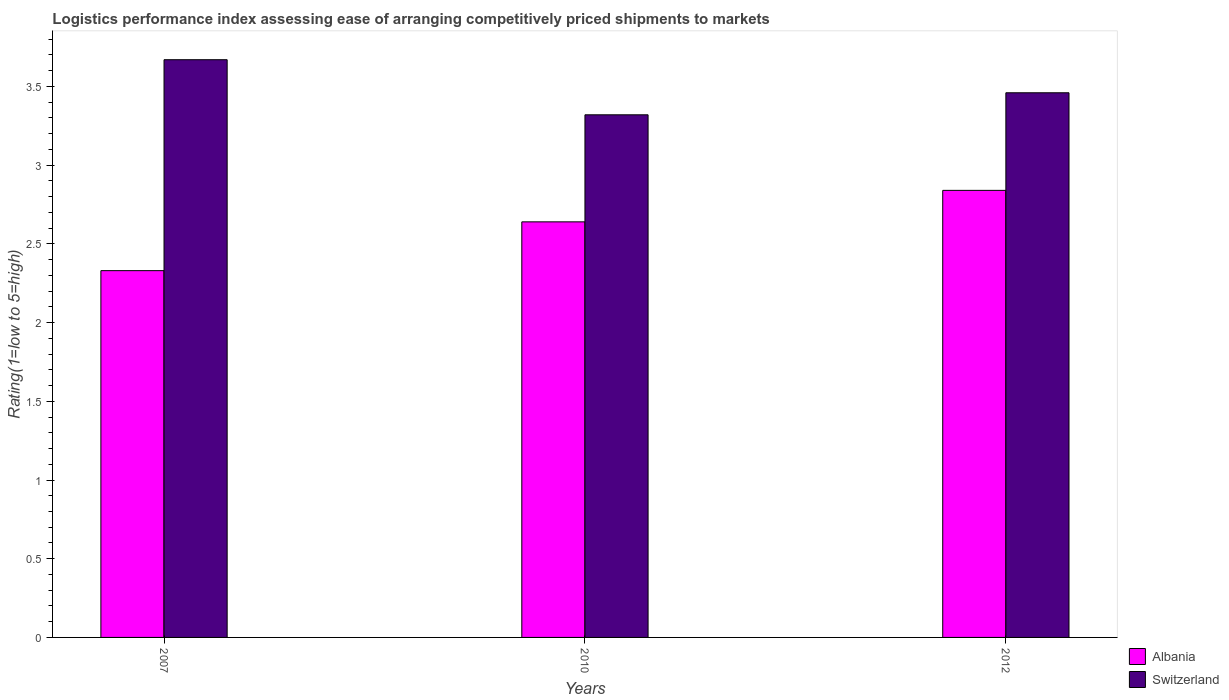How many different coloured bars are there?
Keep it short and to the point. 2. Are the number of bars on each tick of the X-axis equal?
Keep it short and to the point. Yes. How many bars are there on the 3rd tick from the left?
Ensure brevity in your answer.  2. What is the label of the 3rd group of bars from the left?
Ensure brevity in your answer.  2012. What is the Logistic performance index in Switzerland in 2010?
Offer a very short reply. 3.32. Across all years, what is the maximum Logistic performance index in Switzerland?
Your answer should be very brief. 3.67. Across all years, what is the minimum Logistic performance index in Switzerland?
Your answer should be compact. 3.32. In which year was the Logistic performance index in Switzerland minimum?
Provide a succinct answer. 2010. What is the total Logistic performance index in Switzerland in the graph?
Offer a very short reply. 10.45. What is the difference between the Logistic performance index in Switzerland in 2007 and that in 2012?
Your answer should be very brief. 0.21. What is the difference between the Logistic performance index in Albania in 2007 and the Logistic performance index in Switzerland in 2010?
Make the answer very short. -0.99. What is the average Logistic performance index in Albania per year?
Ensure brevity in your answer.  2.6. In the year 2007, what is the difference between the Logistic performance index in Switzerland and Logistic performance index in Albania?
Offer a very short reply. 1.34. What is the ratio of the Logistic performance index in Albania in 2007 to that in 2012?
Provide a short and direct response. 0.82. Is the difference between the Logistic performance index in Switzerland in 2007 and 2012 greater than the difference between the Logistic performance index in Albania in 2007 and 2012?
Provide a succinct answer. Yes. What is the difference between the highest and the second highest Logistic performance index in Albania?
Keep it short and to the point. 0.2. What is the difference between the highest and the lowest Logistic performance index in Albania?
Provide a short and direct response. 0.51. In how many years, is the Logistic performance index in Switzerland greater than the average Logistic performance index in Switzerland taken over all years?
Keep it short and to the point. 1. What does the 1st bar from the left in 2010 represents?
Your answer should be very brief. Albania. What does the 2nd bar from the right in 2012 represents?
Offer a very short reply. Albania. How many years are there in the graph?
Keep it short and to the point. 3. Are the values on the major ticks of Y-axis written in scientific E-notation?
Your response must be concise. No. Where does the legend appear in the graph?
Your answer should be very brief. Bottom right. How are the legend labels stacked?
Your answer should be very brief. Vertical. What is the title of the graph?
Ensure brevity in your answer.  Logistics performance index assessing ease of arranging competitively priced shipments to markets. What is the label or title of the X-axis?
Your answer should be very brief. Years. What is the label or title of the Y-axis?
Make the answer very short. Rating(1=low to 5=high). What is the Rating(1=low to 5=high) of Albania in 2007?
Provide a succinct answer. 2.33. What is the Rating(1=low to 5=high) of Switzerland in 2007?
Offer a terse response. 3.67. What is the Rating(1=low to 5=high) in Albania in 2010?
Make the answer very short. 2.64. What is the Rating(1=low to 5=high) of Switzerland in 2010?
Provide a short and direct response. 3.32. What is the Rating(1=low to 5=high) in Albania in 2012?
Provide a short and direct response. 2.84. What is the Rating(1=low to 5=high) of Switzerland in 2012?
Your answer should be compact. 3.46. Across all years, what is the maximum Rating(1=low to 5=high) in Albania?
Your answer should be compact. 2.84. Across all years, what is the maximum Rating(1=low to 5=high) in Switzerland?
Your answer should be very brief. 3.67. Across all years, what is the minimum Rating(1=low to 5=high) in Albania?
Your response must be concise. 2.33. Across all years, what is the minimum Rating(1=low to 5=high) in Switzerland?
Ensure brevity in your answer.  3.32. What is the total Rating(1=low to 5=high) in Albania in the graph?
Your answer should be very brief. 7.81. What is the total Rating(1=low to 5=high) in Switzerland in the graph?
Offer a terse response. 10.45. What is the difference between the Rating(1=low to 5=high) in Albania in 2007 and that in 2010?
Make the answer very short. -0.31. What is the difference between the Rating(1=low to 5=high) in Switzerland in 2007 and that in 2010?
Keep it short and to the point. 0.35. What is the difference between the Rating(1=low to 5=high) of Albania in 2007 and that in 2012?
Provide a short and direct response. -0.51. What is the difference between the Rating(1=low to 5=high) in Switzerland in 2007 and that in 2012?
Ensure brevity in your answer.  0.21. What is the difference between the Rating(1=low to 5=high) of Switzerland in 2010 and that in 2012?
Ensure brevity in your answer.  -0.14. What is the difference between the Rating(1=low to 5=high) of Albania in 2007 and the Rating(1=low to 5=high) of Switzerland in 2010?
Ensure brevity in your answer.  -0.99. What is the difference between the Rating(1=low to 5=high) in Albania in 2007 and the Rating(1=low to 5=high) in Switzerland in 2012?
Provide a short and direct response. -1.13. What is the difference between the Rating(1=low to 5=high) in Albania in 2010 and the Rating(1=low to 5=high) in Switzerland in 2012?
Give a very brief answer. -0.82. What is the average Rating(1=low to 5=high) in Albania per year?
Make the answer very short. 2.6. What is the average Rating(1=low to 5=high) of Switzerland per year?
Your answer should be compact. 3.48. In the year 2007, what is the difference between the Rating(1=low to 5=high) of Albania and Rating(1=low to 5=high) of Switzerland?
Ensure brevity in your answer.  -1.34. In the year 2010, what is the difference between the Rating(1=low to 5=high) of Albania and Rating(1=low to 5=high) of Switzerland?
Your answer should be very brief. -0.68. In the year 2012, what is the difference between the Rating(1=low to 5=high) in Albania and Rating(1=low to 5=high) in Switzerland?
Your answer should be compact. -0.62. What is the ratio of the Rating(1=low to 5=high) of Albania in 2007 to that in 2010?
Your answer should be compact. 0.88. What is the ratio of the Rating(1=low to 5=high) of Switzerland in 2007 to that in 2010?
Provide a succinct answer. 1.11. What is the ratio of the Rating(1=low to 5=high) in Albania in 2007 to that in 2012?
Ensure brevity in your answer.  0.82. What is the ratio of the Rating(1=low to 5=high) of Switzerland in 2007 to that in 2012?
Your answer should be compact. 1.06. What is the ratio of the Rating(1=low to 5=high) in Albania in 2010 to that in 2012?
Offer a terse response. 0.93. What is the ratio of the Rating(1=low to 5=high) of Switzerland in 2010 to that in 2012?
Offer a terse response. 0.96. What is the difference between the highest and the second highest Rating(1=low to 5=high) in Switzerland?
Your answer should be compact. 0.21. What is the difference between the highest and the lowest Rating(1=low to 5=high) in Albania?
Ensure brevity in your answer.  0.51. 